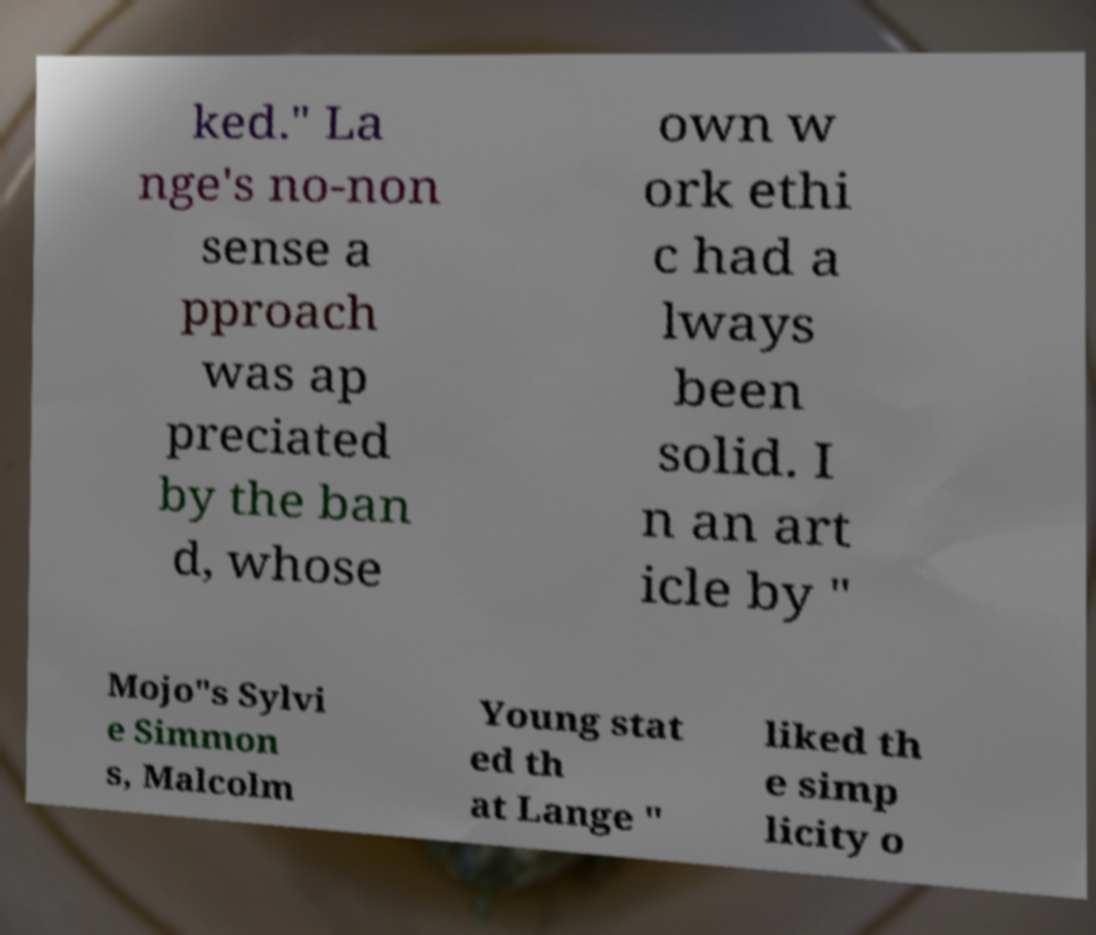Could you assist in decoding the text presented in this image and type it out clearly? ked." La nge's no-non sense a pproach was ap preciated by the ban d, whose own w ork ethi c had a lways been solid. I n an art icle by " Mojo"s Sylvi e Simmon s, Malcolm Young stat ed th at Lange " liked th e simp licity o 